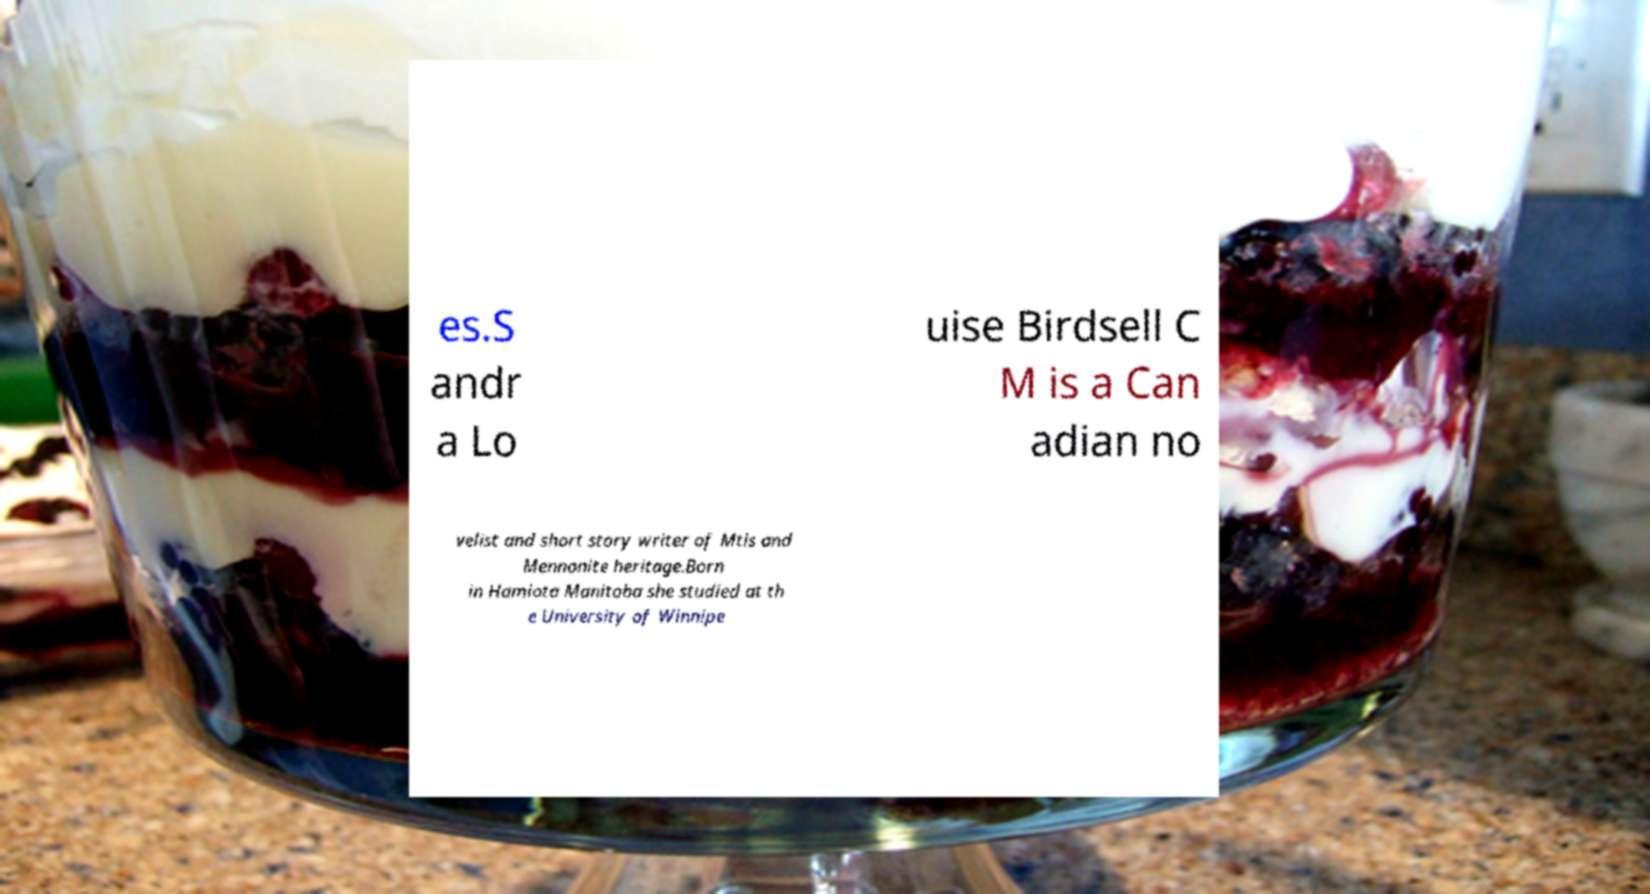Could you extract and type out the text from this image? es.S andr a Lo uise Birdsell C M is a Can adian no velist and short story writer of Mtis and Mennonite heritage.Born in Hamiota Manitoba she studied at th e University of Winnipe 